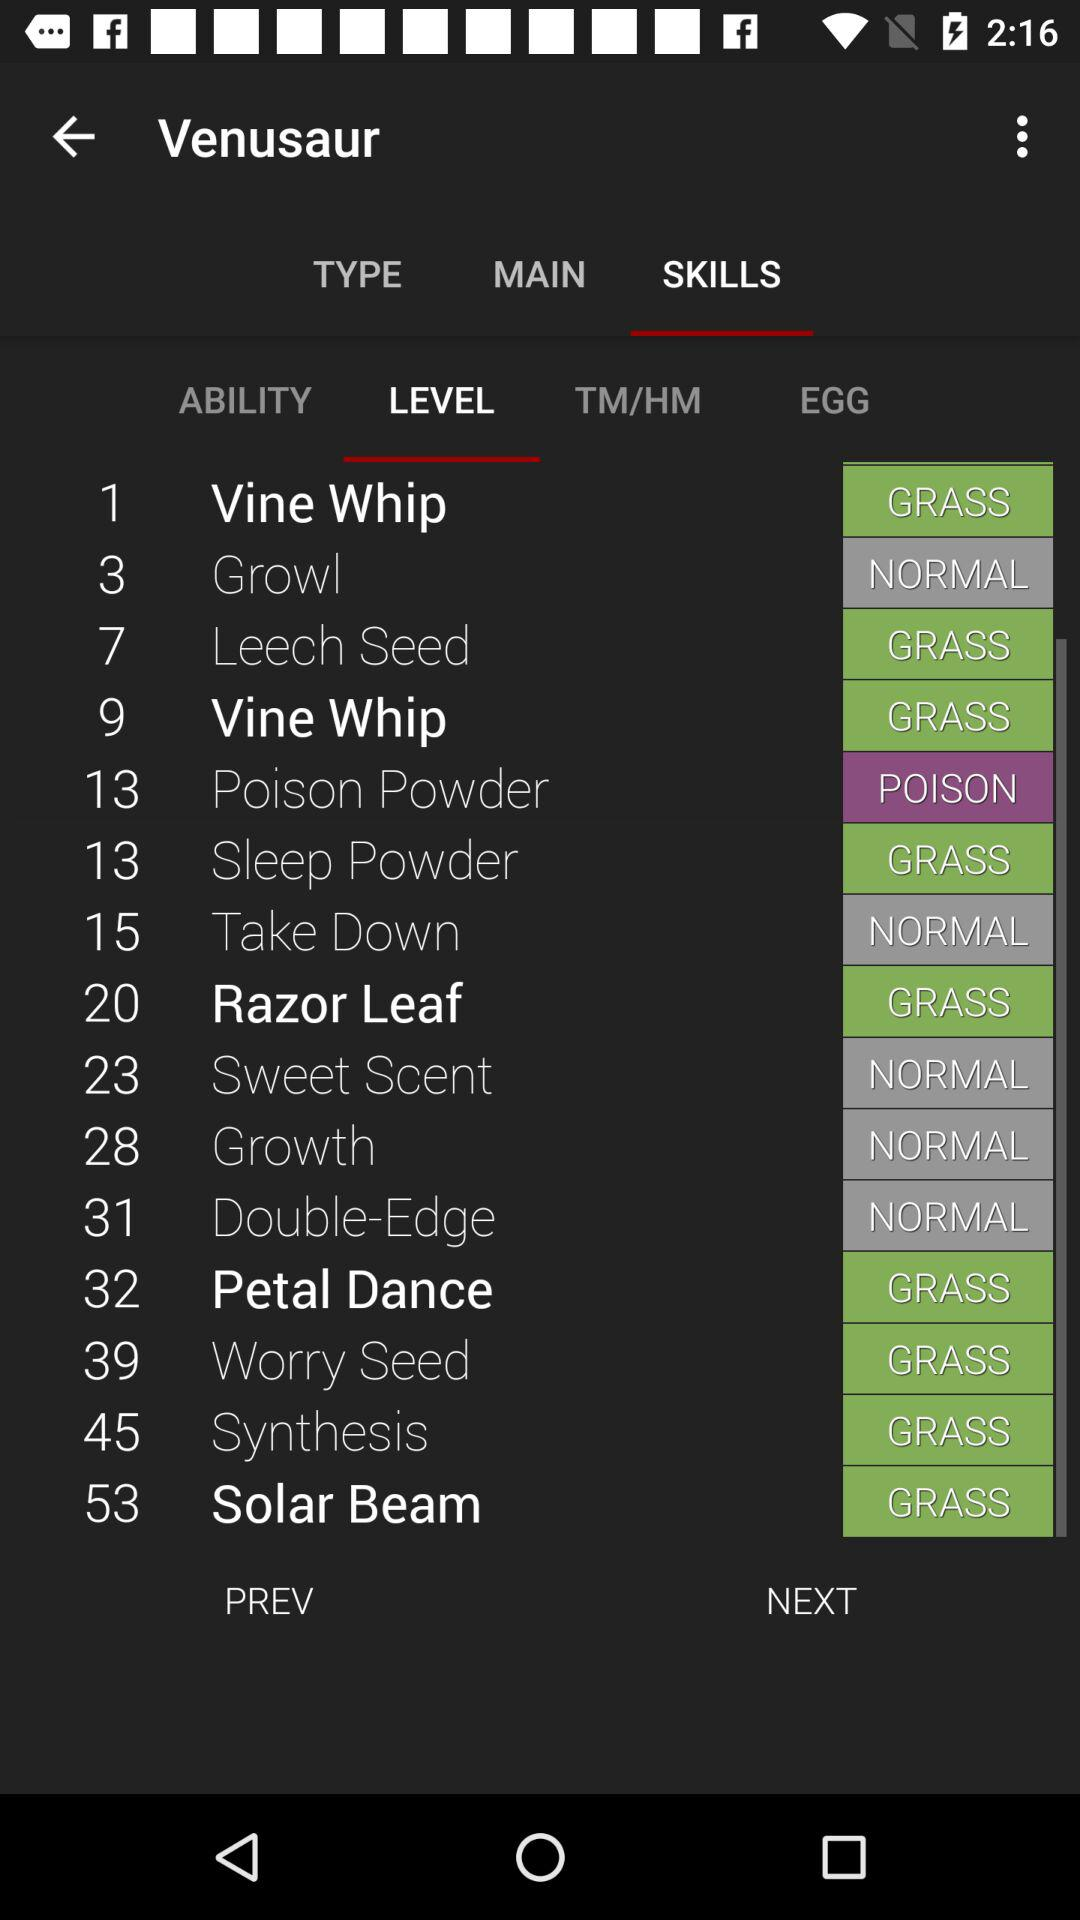What is the type of sweet scent? The type of sweet scent is normal. 